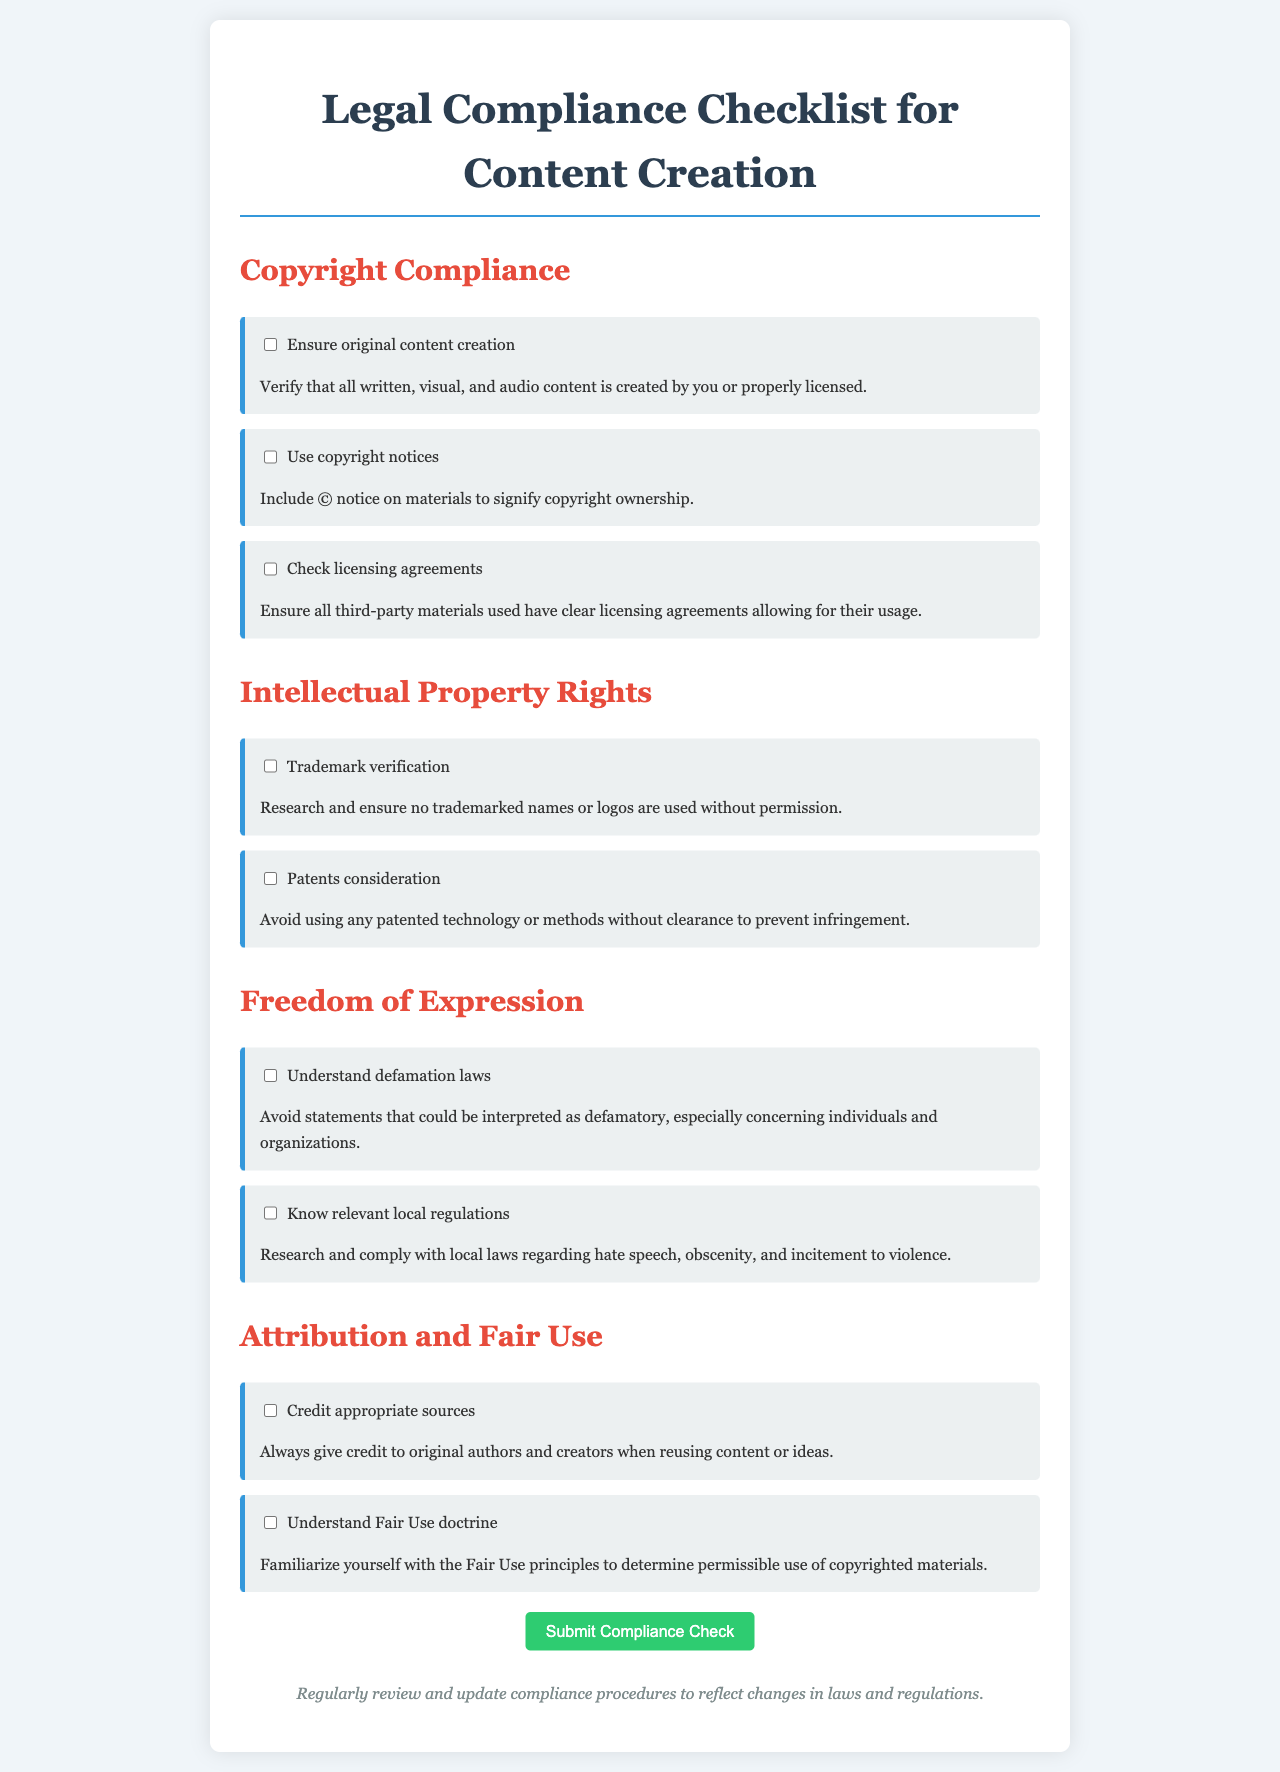What section discusses copyright compliance? The section that discusses copyright compliance is clearly labeled in the document section headings.
Answer: Copyright Compliance How many guidelines are under the Intellectual Property Rights section? The document lists the total number of guidelines under each section, specifically for Intellectual Property Rights.
Answer: 2 What is required under the guideline to credit sources? The guideline specifies the action to be taken when reusing content or ideas, providing specific instructions.
Answer: Always give credit to original authors Which legal concept helps determine permissible use of copyrighted materials? The document mentions a specific legal doctrine related to copyright usage, indicating a key term.
Answer: Fair Use What should be included to signify copyright ownership? The document clearly states an important mark that indicates ownership of the original content.
Answer: © notice What does the guideline for understanding defamation laws advise against? It highlights a specific action related to statements that could lead to legal issues, focusing on the nature of those statements.
Answer: Defamatory statements Under the Freedom of Expression section, what does the guideline about local regulations mention? The guideline emphasizes the importance of awareness regarding specific laws in various locales.
Answer: Local laws How should third-party materials be handled according to the guidelines? A clear requirement is mentioned regarding the agreements for the utilization of others' materials.
Answer: Check licensing agreements 